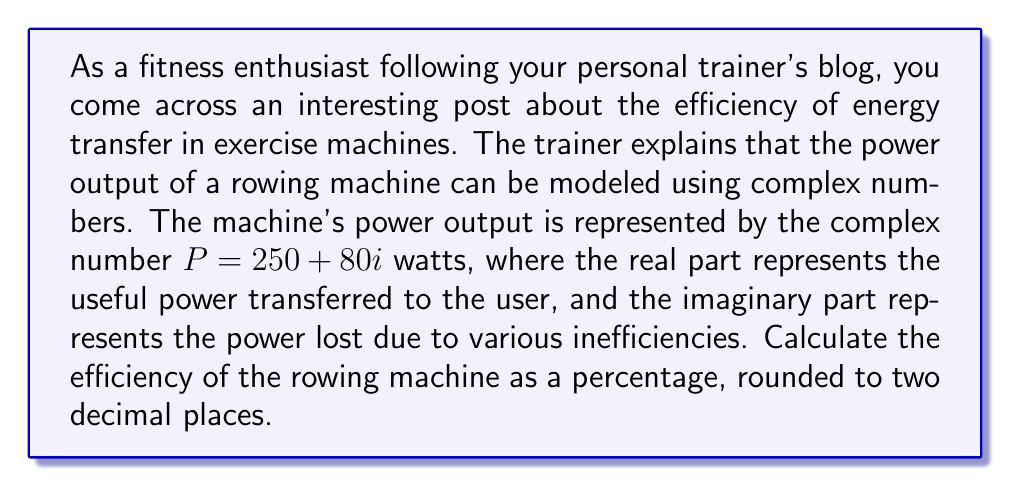Solve this math problem. To solve this problem, we need to understand the concept of complex power and how it relates to efficiency. Let's break it down step-by-step:

1) The given complex power is $P = 250 + 80i$ watts.

2) In complex power analysis:
   - The real part represents the active (useful) power
   - The imaginary part represents the reactive (lost) power

3) The magnitude of the complex power, also known as the apparent power, is given by:

   $|P| = \sqrt{(\text{Re}(P))^2 + (\text{Im}(P))^2}$

   Where $\text{Re}(P)$ is the real part and $\text{Im}(P)$ is the imaginary part.

4) Let's calculate the apparent power:

   $|P| = \sqrt{250^2 + 80^2} = \sqrt{62500 + 6400} = \sqrt{68900} \approx 262.49$ watts

5) The efficiency is the ratio of useful power to apparent power, expressed as a percentage:

   $\text{Efficiency} = \frac{\text{Useful Power}}{\text{Apparent Power}} \times 100\%$

6) In this case:
   Useful Power = $\text{Re}(P) = 250$ watts
   Apparent Power = $|P| \approx 262.49$ watts

7) Calculate the efficiency:

   $\text{Efficiency} = \frac{250}{262.49} \times 100\% \approx 95.24\%$

Therefore, the efficiency of the rowing machine is approximately 95.24%.
Answer: 95.24% 